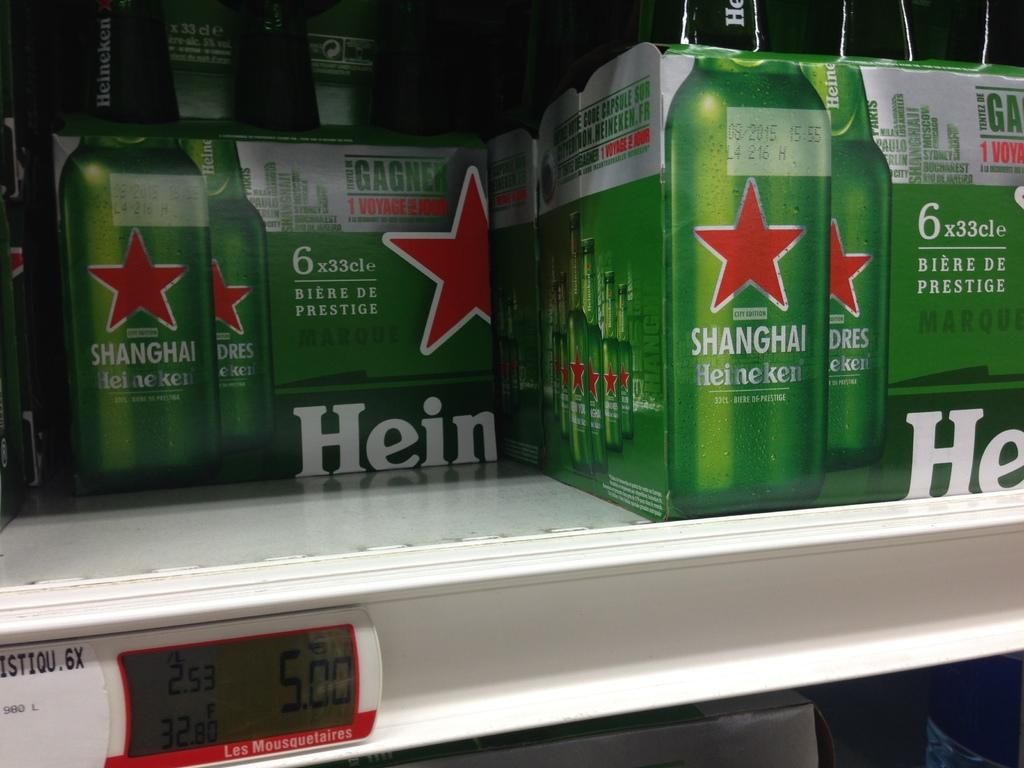<image>
Create a compact narrative representing the image presented. The shelf contains several boxes of Heineken beers. 